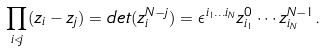Convert formula to latex. <formula><loc_0><loc_0><loc_500><loc_500>\prod _ { i < j } ( z _ { i } - z _ { j } ) = d e t ( z _ { i } ^ { N - j } ) = \epsilon ^ { i _ { 1 } \dots i _ { N } } z _ { i _ { 1 } } ^ { 0 } \cdots z _ { i _ { N } } ^ { N - 1 } .</formula> 